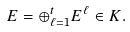<formula> <loc_0><loc_0><loc_500><loc_500>E = \oplus _ { \ell = 1 } ^ { t } E ^ { \ell } \in K .</formula> 